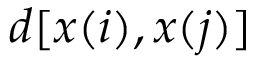Convert formula to latex. <formula><loc_0><loc_0><loc_500><loc_500>d [ x ( i ) , x ( j ) ]</formula> 